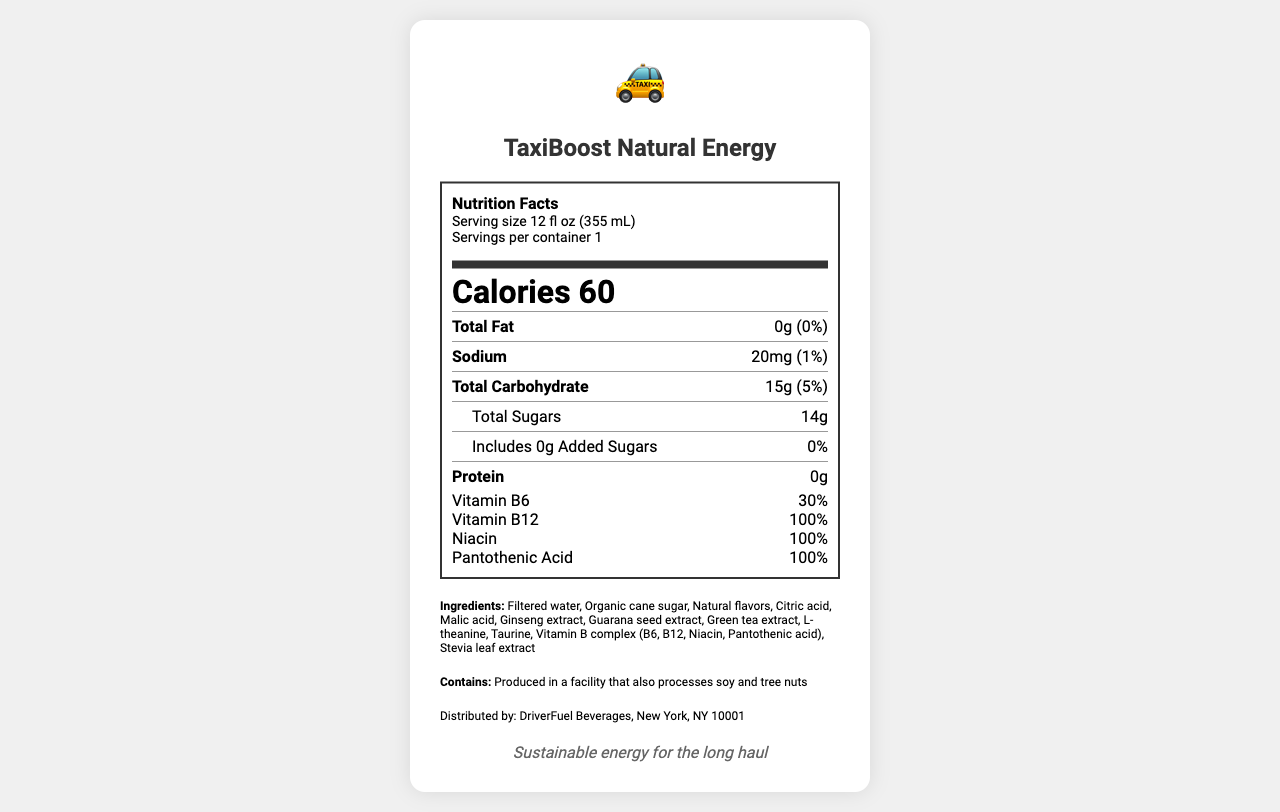what is the serving size of TaxiBoost Natural Energy? The serving size is noted right at the top of the nutrition facts label and specifies that it is 12 fl oz (355 mL).
Answer: 12 fl oz (355 mL) how many calories are in one serving? The calories per serving are prominently displayed in large font in the document.
Answer: 60 what is the total amount of sugars in TaxiBoost Natural Energy? Under the Total Carbohydrate section, it lists that there are 14g of Total Sugars.
Answer: 14g what is the daily value percentage of Vitamin B12? The Vitamin B12 daily value percentage is listed as 100% under the Vitamins section at the bottom of the nutritional facts.
Answer: 100% which vitamins have a daily value percentage of exactly 100%? A. Vitamin B6 B. Vitamin B12 C. Niacin D. Pantothenic Acid Vitamin B12, Niacin, and Pantothenic Acid all have a 100% daily value as indicated under the Vitamins section.
Answer: B, C, D what is the main source of sweetener used in this energy drink? The ingredients list includes Organic cane sugar as the second ingredient, indicating it's the primary sweetener.
Answer: Organic cane sugar is the drink caffeinated? The drink is described as caffeine-free in the product description paragraph.
Answer: No does the energy drink contain any allergens? This information is explicitly mentioned under the allergen information section.
Answer: Contains: Produced in a facility that also processes soy and tree nuts how much sodium is in one serving? Sodium content of 20mg is listed in the nutrition facts section.
Answer: 20mg what kind of ingredients are used in TaxiBoost Natural Energy? The product description states that the energy drink is made with natural ingredients.
Answer: Natural ingredients summarize the document. This summary captures the main purpose, nutritional benefits, and ingredient composition of TaxiBoost Natural Energy.
Answer: TaxiBoost Natural Energy is a caffeine-free energy drink designed for taxi drivers. It provides sustained alertness through natural ingredients without causing jitters or a crash. The drink contains 60 calories per serving, with no fat or protein, low sodium, and includes vitamins B6, B12, Niacin, and Pantothenic Acid. It is sweetened primarily with organic cane sugar and contains no added sugars. Ingredients include ginseng extract, guarana seed extract, green tea extract, and taurine, among others. The product is free from common allergens but is produced in a facility that processes soy and tree nuts. what is the source of the distribution information? The distribution information is given at the bottom of the document, naming DriverFuel Beverages as the distributor and providing a location.
Answer: Distributed by: DriverFuel Beverages, New York, NY 10001 which ingredient is present in the largest amount after water? A. Organic cane sugar B. Natural flavors C. Malic acid D. Ginseng extract The ingredients are listed in order of predominance, and Organic cane sugar is the second listed after Filtered water.
Answer: A can you determine the price of TaxiBoost Natural Energy from the document? The document does not provide any pricing information.
Answer: Not enough information 